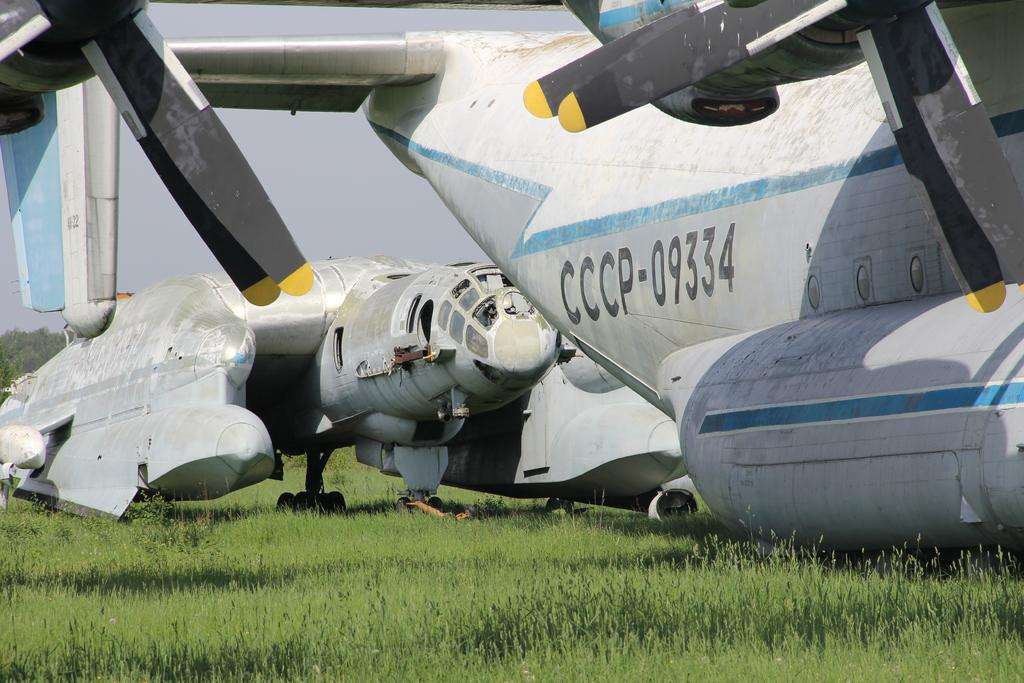Provide a one-sentence caption for the provided image. Airplane CCCP-09334 that has black propellers sits on the grass. 